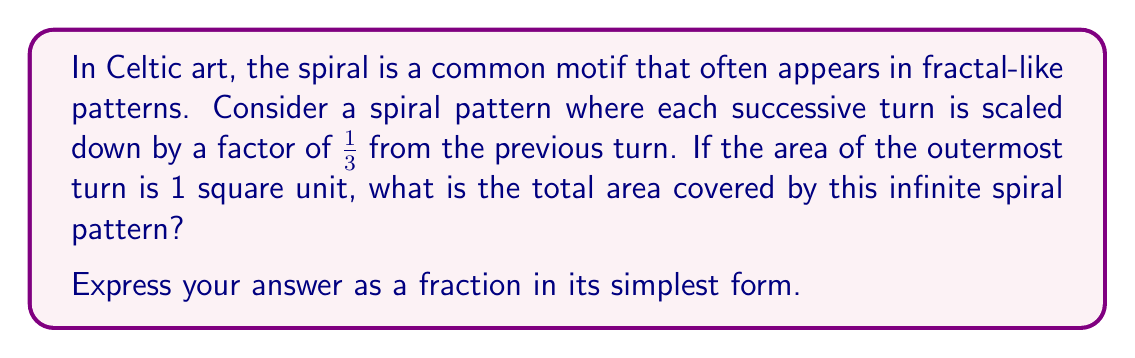What is the answer to this math problem? Let's approach this step-by-step:

1) First, we need to recognize that this is a geometric series. The areas of the successive turns form a sequence:

   $1, (\frac{1}{3})^2, (\frac{1}{3})^4, (\frac{1}{3})^6, ...$

2) The general term of this sequence can be written as:

   $a_n = (\frac{1}{3})^{2(n-1)}$ for $n \geq 1$

3) The sum of an infinite geometric series is given by the formula:

   $S_{\infty} = \frac{a_1}{1-r}$

   where $a_1$ is the first term and $r$ is the common ratio.

4) In our case:
   $a_1 = 1$
   $r = (\frac{1}{3})^2 = \frac{1}{9}$

5) Substituting these into our formula:

   $$S_{\infty} = \frac{1}{1-\frac{1}{9}} = \frac{1}{\frac{9}{9}-\frac{1}{9}} = \frac{1}{\frac{8}{9}} = \frac{9}{8}$$

6) Therefore, the total area covered by the infinite spiral is $\frac{9}{8}$ square units.

This result reflects the fractal nature of the pattern: despite being made up of an infinite number of turns, the total area converges to a finite value.
Answer: $\frac{9}{8}$ square units 